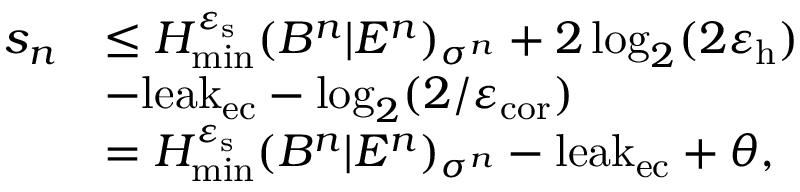Convert formula to latex. <formula><loc_0><loc_0><loc_500><loc_500>\begin{array} { r l } { s _ { n } } & { \leq H _ { \min } ^ { \varepsilon _ { s } } ( B ^ { n } | E ^ { n } ) _ { \sigma ^ { n } } + 2 \log _ { 2 } ( 2 \varepsilon _ { h } ) } \\ & { - l e a k _ { e c } - \log _ { 2 } ( 2 / \varepsilon _ { c o r } ) } \\ & { = H _ { \min } ^ { \varepsilon _ { s } } ( B ^ { n } | E ^ { n } ) _ { \sigma ^ { n } } - l e a k _ { e c } + \theta , } \end{array}</formula> 